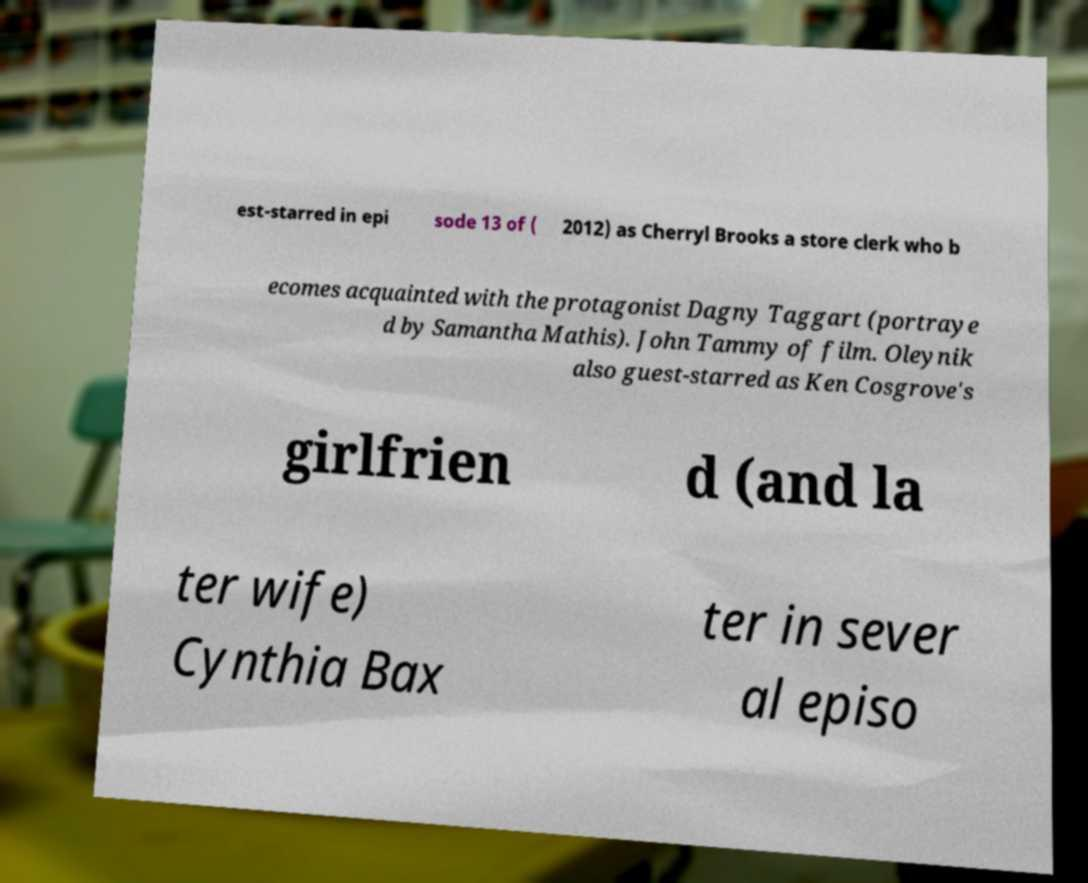Can you accurately transcribe the text from the provided image for me? est-starred in epi sode 13 of ( 2012) as Cherryl Brooks a store clerk who b ecomes acquainted with the protagonist Dagny Taggart (portraye d by Samantha Mathis). John Tammy of film. Oleynik also guest-starred as Ken Cosgrove's girlfrien d (and la ter wife) Cynthia Bax ter in sever al episo 